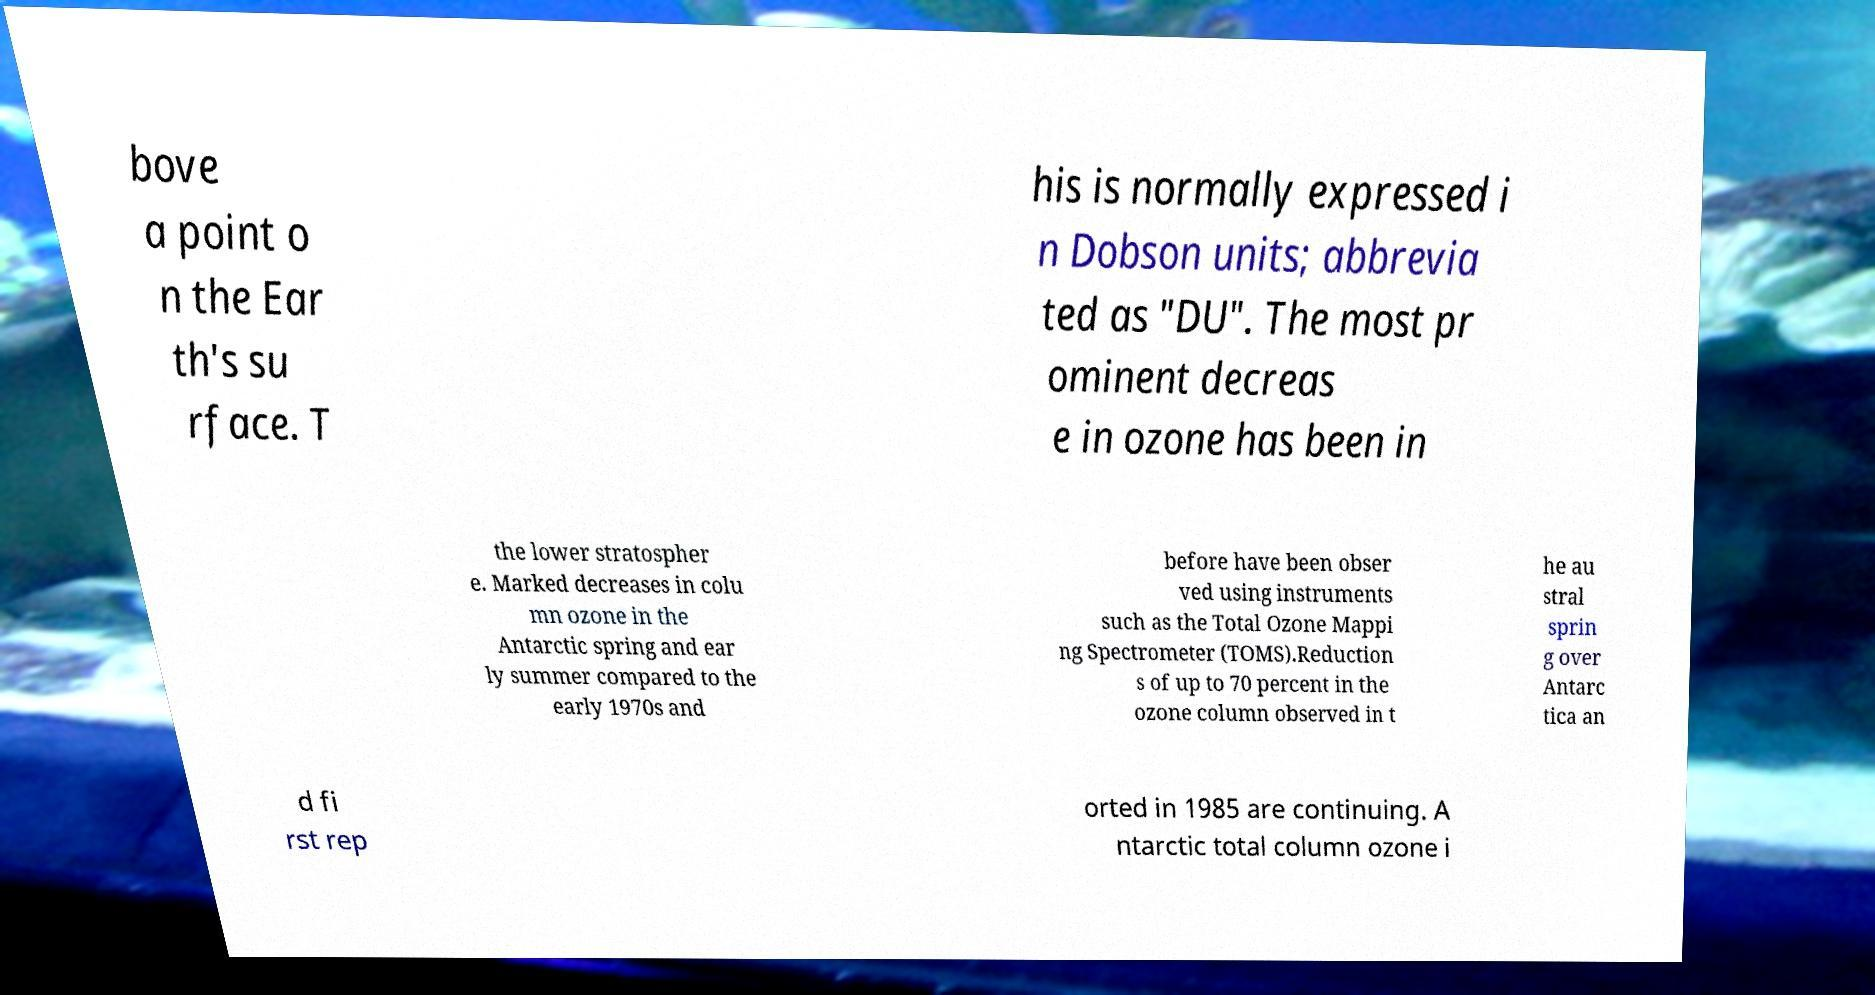Could you extract and type out the text from this image? bove a point o n the Ear th's su rface. T his is normally expressed i n Dobson units; abbrevia ted as "DU". The most pr ominent decreas e in ozone has been in the lower stratospher e. Marked decreases in colu mn ozone in the Antarctic spring and ear ly summer compared to the early 1970s and before have been obser ved using instruments such as the Total Ozone Mappi ng Spectrometer (TOMS).Reduction s of up to 70 percent in the ozone column observed in t he au stral sprin g over Antarc tica an d fi rst rep orted in 1985 are continuing. A ntarctic total column ozone i 